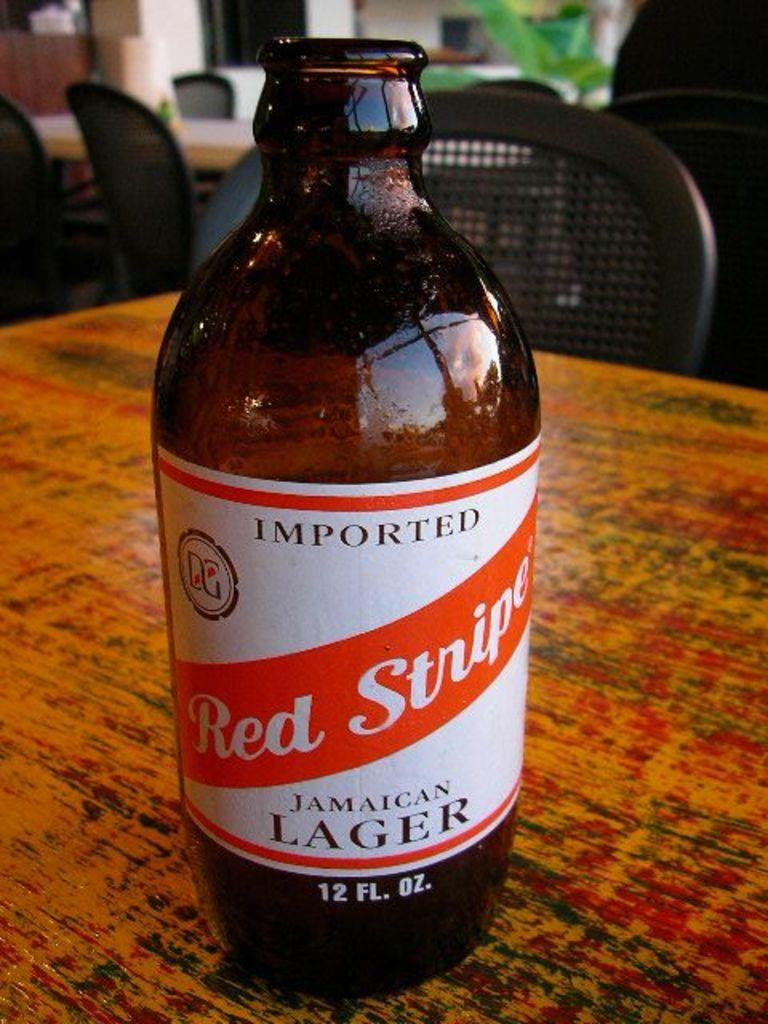What object is on the table in the image? There is a bottle on the table in the image. What can be seen in the background of the image? In the background, there are chairs, another table, a plant, and a wall. Can you describe the other table in the background? The other table in the background is similar to the table with the bottle, but it is not the main focus of the image. What type of vegetation is present in the background? There is a plant in the background. What type of tub is visible in the image? There is no tub present in the image. 